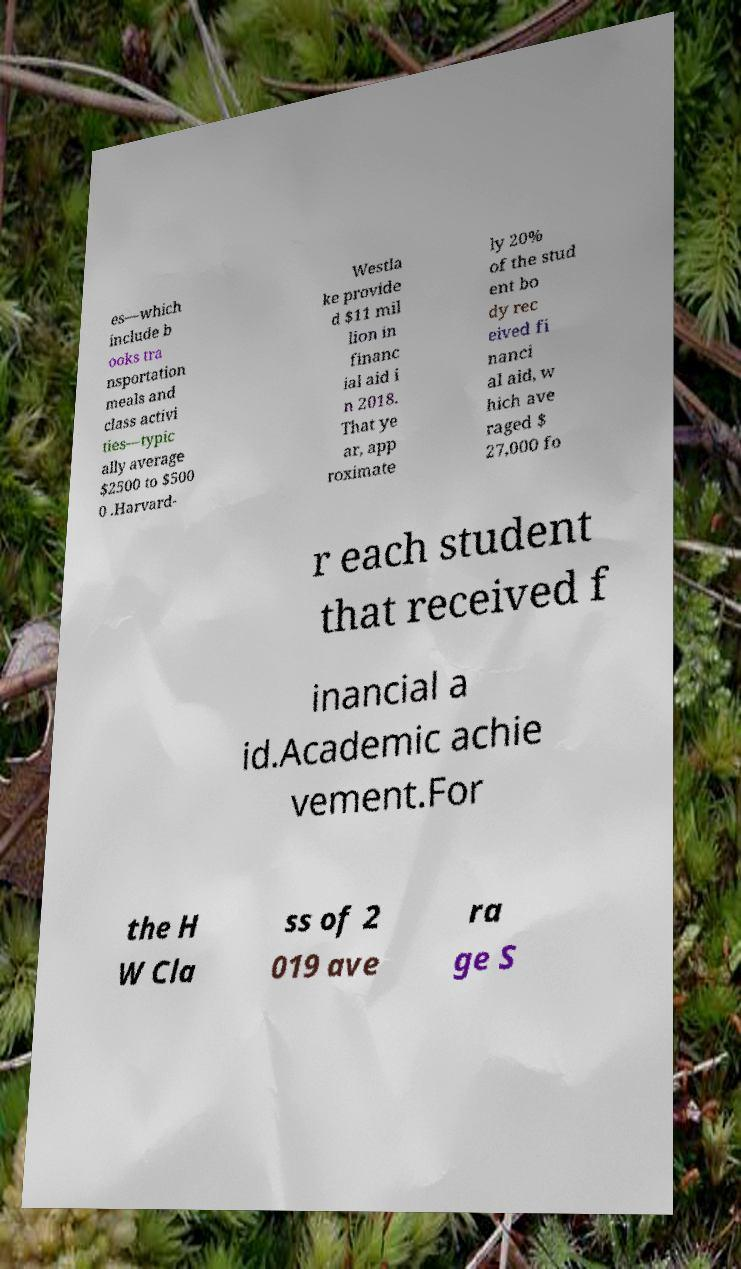Can you read and provide the text displayed in the image?This photo seems to have some interesting text. Can you extract and type it out for me? es—which include b ooks tra nsportation meals and class activi ties—typic ally average $2500 to $500 0 .Harvard- Westla ke provide d $11 mil lion in financ ial aid i n 2018. That ye ar, app roximate ly 20% of the stud ent bo dy rec eived fi nanci al aid, w hich ave raged $ 27,000 fo r each student that received f inancial a id.Academic achie vement.For the H W Cla ss of 2 019 ave ra ge S 